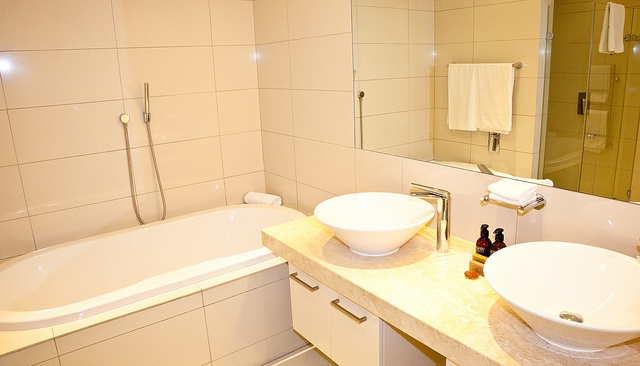Describe the objects in this image and their specific colors. I can see sink in tan and ivory tones, sink in tan and ivory tones, bottle in tan, black, maroon, and brown tones, and bottle in tan, black, maroon, and gray tones in this image. 